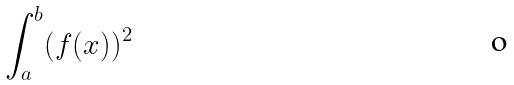Convert formula to latex. <formula><loc_0><loc_0><loc_500><loc_500>\int _ { a } ^ { b } ( f ( x ) ) ^ { 2 }</formula> 